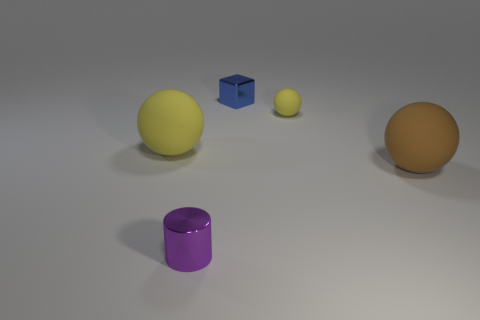Is the tiny blue object the same shape as the large brown rubber thing?
Your answer should be very brief. No. What number of objects are either matte objects that are to the left of the metal block or blue rubber objects?
Keep it short and to the point. 1. Are there an equal number of metal blocks that are to the left of the tiny metallic block and small blue blocks that are on the left side of the small cylinder?
Offer a very short reply. Yes. How many other objects are there of the same shape as the small yellow object?
Offer a very short reply. 2. Is the size of the rubber thing that is left of the metallic cylinder the same as the metal thing behind the big yellow object?
Your response must be concise. No. How many balls are either shiny objects or gray objects?
Give a very brief answer. 0. What number of shiny objects are purple cylinders or small blue blocks?
Ensure brevity in your answer.  2. What is the size of the brown object that is the same shape as the small yellow thing?
Your answer should be very brief. Large. Is there any other thing that is the same size as the shiny cylinder?
Your answer should be compact. Yes. Does the brown ball have the same size as the shiny object left of the tiny blue block?
Your response must be concise. No. 